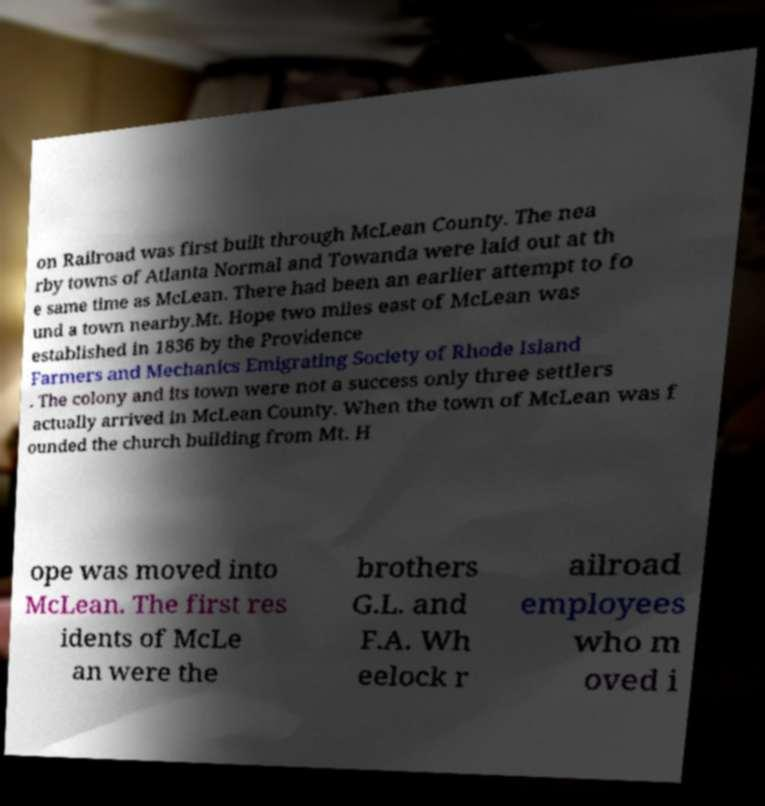Please read and relay the text visible in this image. What does it say? on Railroad was first built through McLean County. The nea rby towns of Atlanta Normal and Towanda were laid out at th e same time as McLean. There had been an earlier attempt to fo und a town nearby.Mt. Hope two miles east of McLean was established in 1836 by the Providence Farmers and Mechanics Emigrating Society of Rhode Island . The colony and its town were not a success only three settlers actually arrived in McLean County. When the town of McLean was f ounded the church building from Mt. H ope was moved into McLean. The first res idents of McLe an were the brothers G.L. and F.A. Wh eelock r ailroad employees who m oved i 